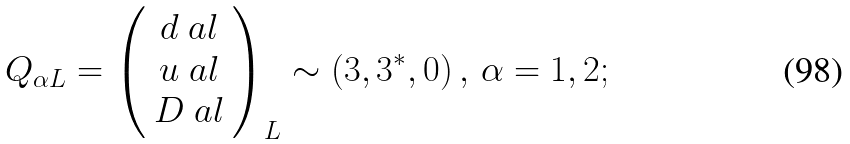Convert formula to latex. <formula><loc_0><loc_0><loc_500><loc_500>Q _ { \alpha L } = \left ( \begin{array} { c } d _ { \ } a l \\ u _ { \ } a l \\ D _ { \ } a l \end{array} \right ) _ { L } \sim \left ( { 3 } , { 3 ^ { * } } , 0 \right ) , \, \alpha = 1 , 2 ;</formula> 